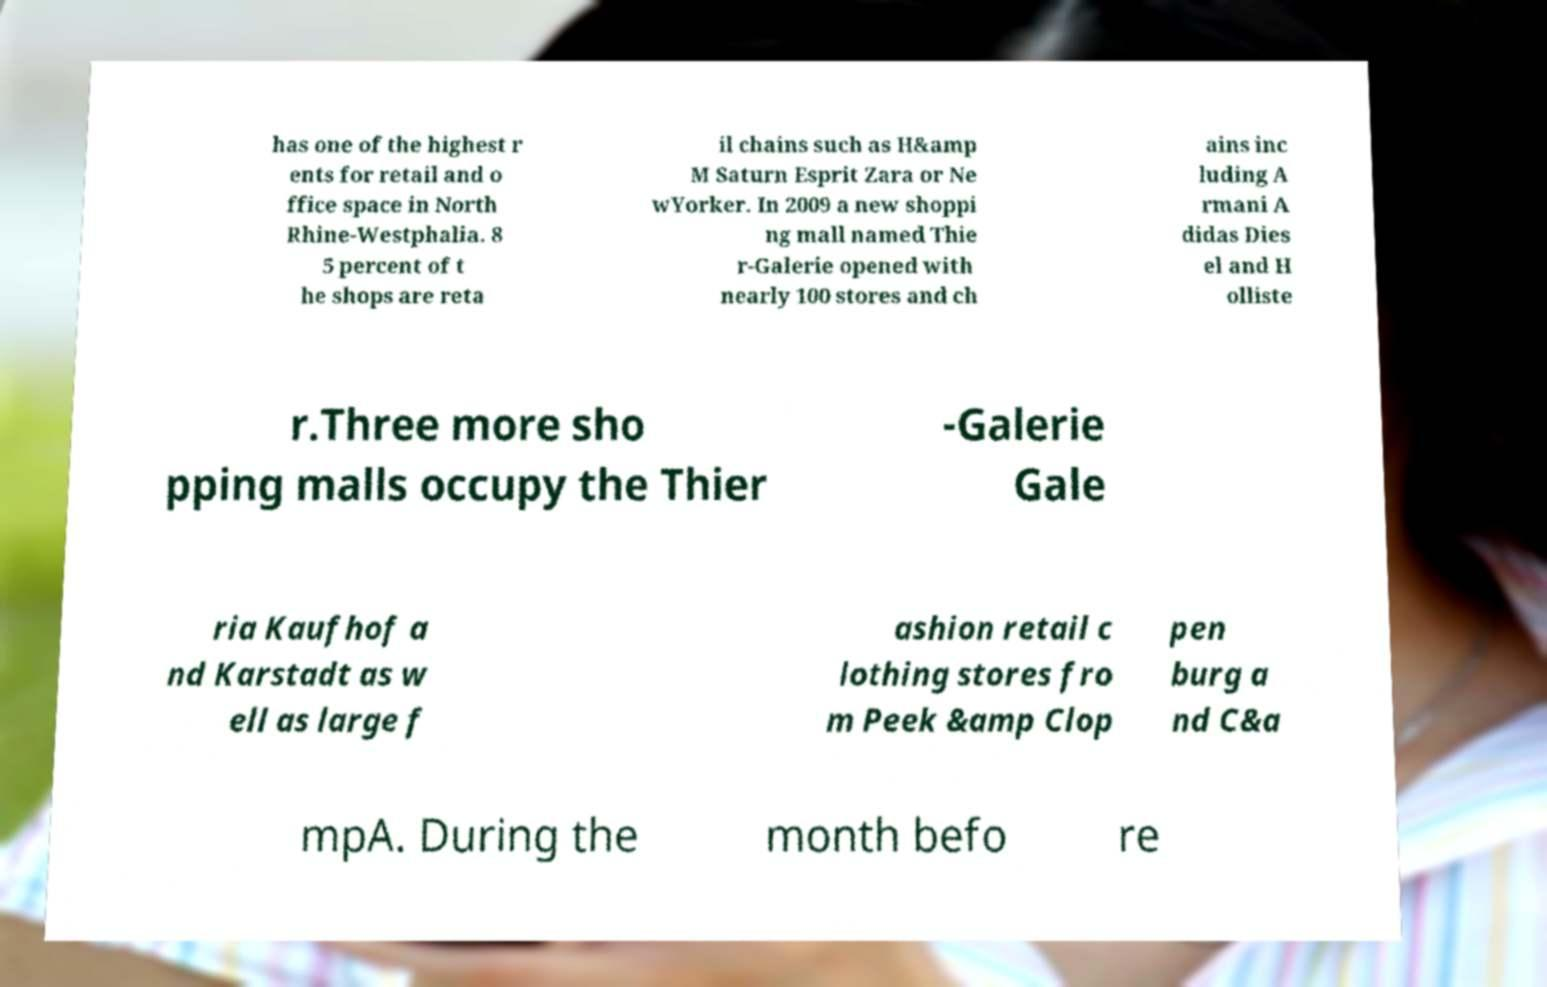Could you assist in decoding the text presented in this image and type it out clearly? has one of the highest r ents for retail and o ffice space in North Rhine-Westphalia. 8 5 percent of t he shops are reta il chains such as H&amp M Saturn Esprit Zara or Ne wYorker. In 2009 a new shoppi ng mall named Thie r-Galerie opened with nearly 100 stores and ch ains inc luding A rmani A didas Dies el and H olliste r.Three more sho pping malls occupy the Thier -Galerie Gale ria Kaufhof a nd Karstadt as w ell as large f ashion retail c lothing stores fro m Peek &amp Clop pen burg a nd C&a mpA. During the month befo re 